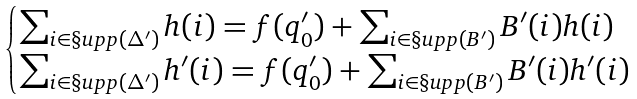Convert formula to latex. <formula><loc_0><loc_0><loc_500><loc_500>\begin{cases} \sum _ { i \in \S u p p ( \Delta ^ { \prime } ) } h ( i ) = f ( q ^ { \prime } _ { 0 } ) + \sum _ { i \in \S u p p ( B ^ { \prime } ) } B ^ { \prime } ( i ) h ( i ) \\ \sum _ { i \in \S u p p ( \Delta ^ { \prime } ) } h ^ { \prime } ( i ) = f ( q ^ { \prime } _ { 0 } ) + \sum _ { i \in \S u p p ( B ^ { \prime } ) } B ^ { \prime } ( i ) h ^ { \prime } ( i ) \end{cases}</formula> 